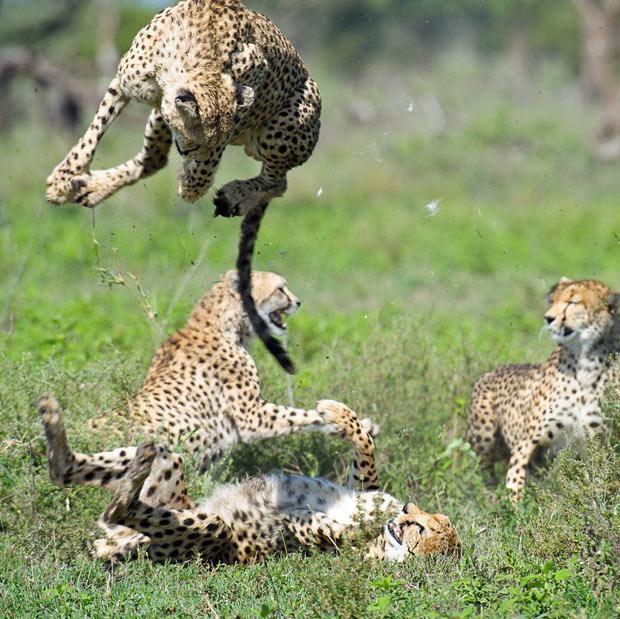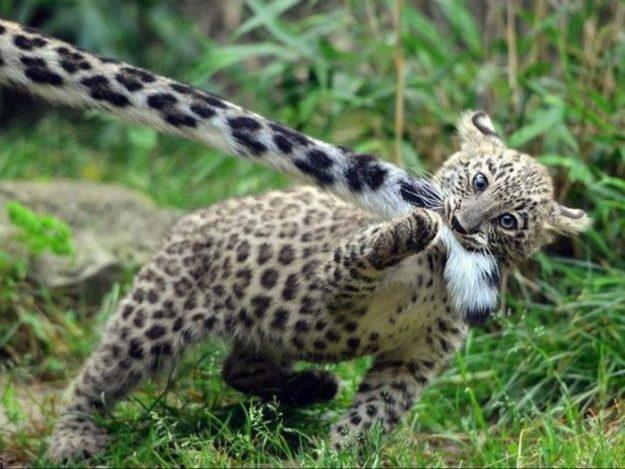The first image is the image on the left, the second image is the image on the right. For the images displayed, is the sentence "An image shows one spotted wild cat pursuing its prey." factually correct? Answer yes or no. No. The first image is the image on the left, the second image is the image on the right. Evaluate the accuracy of this statement regarding the images: "The leopard on the left is running after its prey.". Is it true? Answer yes or no. No. 